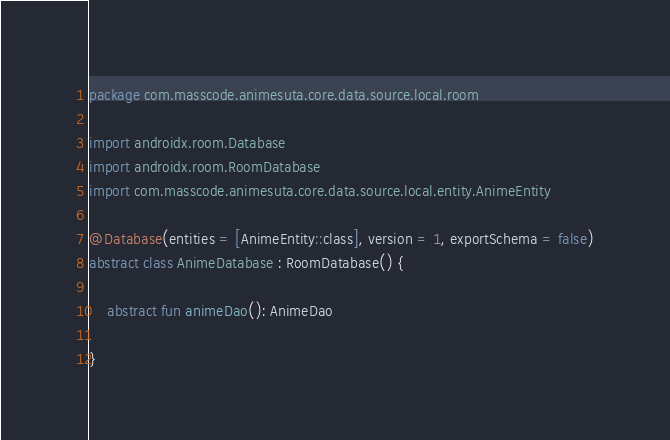Convert code to text. <code><loc_0><loc_0><loc_500><loc_500><_Kotlin_>package com.masscode.animesuta.core.data.source.local.room

import androidx.room.Database
import androidx.room.RoomDatabase
import com.masscode.animesuta.core.data.source.local.entity.AnimeEntity

@Database(entities = [AnimeEntity::class], version = 1, exportSchema = false)
abstract class AnimeDatabase : RoomDatabase() {

    abstract fun animeDao(): AnimeDao

}</code> 